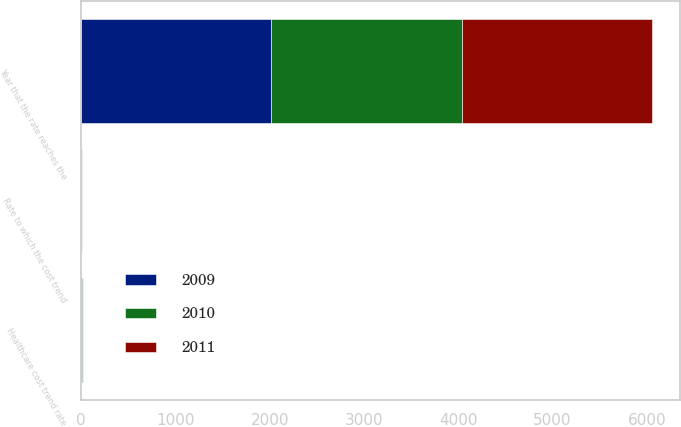Convert chart to OTSL. <chart><loc_0><loc_0><loc_500><loc_500><stacked_bar_chart><ecel><fcel>Healthcare cost trend rate<fcel>Rate to which the cost trend<fcel>Year that the rate reaches the<nl><fcel>2010<fcel>7.4<fcel>4.5<fcel>2018<nl><fcel>2011<fcel>7.9<fcel>4.5<fcel>2018<nl><fcel>2009<fcel>8.4<fcel>4.5<fcel>2018<nl></chart> 